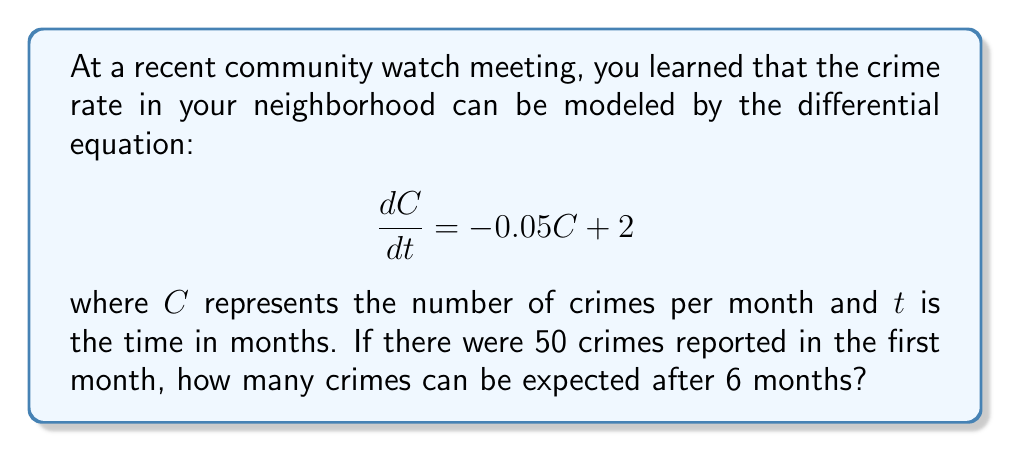Show me your answer to this math problem. Let's approach this step-by-step:

1) We have a first-order linear differential equation:
   $$\frac{dC}{dt} = -0.05C + 2$$

2) The general solution for this type of equation is:
   $$C(t) = Ce^{-0.05t} + 40$$
   where $C$ is a constant we need to determine.

3) We know that at $t=0$ (the first month), $C=50$. Let's use this initial condition:
   $$50 = C + 40$$
   $$C = 10$$

4) So, our particular solution is:
   $$C(t) = 10e^{-0.05t} + 40$$

5) Now, we want to find $C(6)$, the number of crimes after 6 months:
   $$C(6) = 10e^{-0.05(6)} + 40$$
   $$C(6) = 10e^{-0.3} + 40$$

6) Using a calculator or computer:
   $$C(6) \approx 10(0.7408) + 40 \approx 47.408$$

7) Since we're dealing with crimes, we round to the nearest whole number.
Answer: After 6 months, approximately 47 crimes can be expected. 